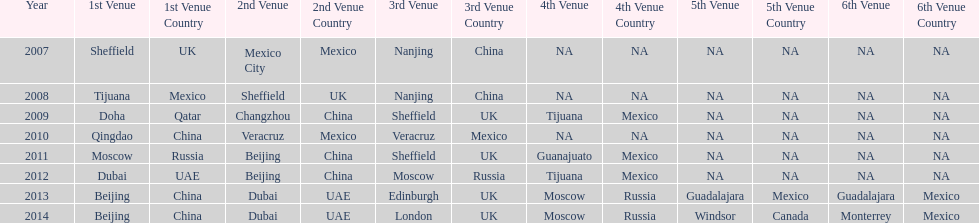Name a year whose second venue was the same as 2011. 2012. 